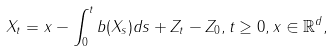Convert formula to latex. <formula><loc_0><loc_0><loc_500><loc_500>X _ { t } = x - \int _ { 0 } ^ { t } b ( X _ { s } ) d s + Z _ { t } - Z _ { 0 } , t \geq 0 , x \in \mathbb { R } ^ { d } ,</formula> 